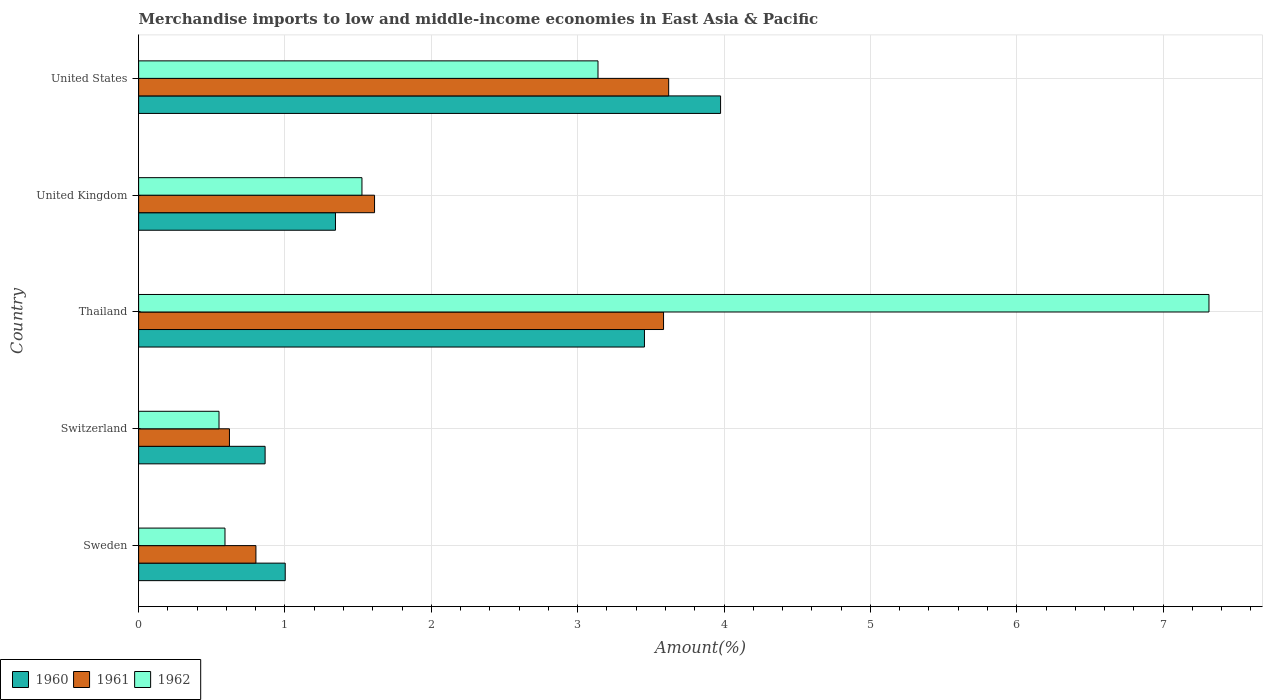How many groups of bars are there?
Ensure brevity in your answer.  5. Are the number of bars on each tick of the Y-axis equal?
Keep it short and to the point. Yes. How many bars are there on the 4th tick from the bottom?
Ensure brevity in your answer.  3. What is the label of the 3rd group of bars from the top?
Your response must be concise. Thailand. What is the percentage of amount earned from merchandise imports in 1961 in United Kingdom?
Keep it short and to the point. 1.61. Across all countries, what is the maximum percentage of amount earned from merchandise imports in 1962?
Provide a succinct answer. 7.31. Across all countries, what is the minimum percentage of amount earned from merchandise imports in 1961?
Your answer should be compact. 0.62. In which country was the percentage of amount earned from merchandise imports in 1961 minimum?
Give a very brief answer. Switzerland. What is the total percentage of amount earned from merchandise imports in 1960 in the graph?
Your response must be concise. 10.64. What is the difference between the percentage of amount earned from merchandise imports in 1962 in Switzerland and that in United Kingdom?
Ensure brevity in your answer.  -0.98. What is the difference between the percentage of amount earned from merchandise imports in 1962 in United Kingdom and the percentage of amount earned from merchandise imports in 1961 in Switzerland?
Provide a short and direct response. 0.91. What is the average percentage of amount earned from merchandise imports in 1960 per country?
Offer a terse response. 2.13. What is the difference between the percentage of amount earned from merchandise imports in 1961 and percentage of amount earned from merchandise imports in 1962 in United Kingdom?
Make the answer very short. 0.09. In how many countries, is the percentage of amount earned from merchandise imports in 1960 greater than 4.2 %?
Keep it short and to the point. 0. What is the ratio of the percentage of amount earned from merchandise imports in 1962 in Sweden to that in Thailand?
Offer a terse response. 0.08. Is the percentage of amount earned from merchandise imports in 1962 in Sweden less than that in Switzerland?
Your answer should be very brief. No. Is the difference between the percentage of amount earned from merchandise imports in 1961 in Thailand and United States greater than the difference between the percentage of amount earned from merchandise imports in 1962 in Thailand and United States?
Provide a succinct answer. No. What is the difference between the highest and the second highest percentage of amount earned from merchandise imports in 1962?
Offer a very short reply. 4.17. What is the difference between the highest and the lowest percentage of amount earned from merchandise imports in 1962?
Your response must be concise. 6.76. Is the sum of the percentage of amount earned from merchandise imports in 1961 in Sweden and Thailand greater than the maximum percentage of amount earned from merchandise imports in 1960 across all countries?
Your answer should be compact. Yes. What does the 3rd bar from the top in Switzerland represents?
Your answer should be compact. 1960. What does the 1st bar from the bottom in United States represents?
Keep it short and to the point. 1960. Is it the case that in every country, the sum of the percentage of amount earned from merchandise imports in 1960 and percentage of amount earned from merchandise imports in 1961 is greater than the percentage of amount earned from merchandise imports in 1962?
Your answer should be compact. No. Are the values on the major ticks of X-axis written in scientific E-notation?
Ensure brevity in your answer.  No. Does the graph contain grids?
Give a very brief answer. Yes. Where does the legend appear in the graph?
Your answer should be compact. Bottom left. How many legend labels are there?
Offer a terse response. 3. How are the legend labels stacked?
Make the answer very short. Horizontal. What is the title of the graph?
Offer a terse response. Merchandise imports to low and middle-income economies in East Asia & Pacific. Does "1987" appear as one of the legend labels in the graph?
Make the answer very short. No. What is the label or title of the X-axis?
Give a very brief answer. Amount(%). What is the label or title of the Y-axis?
Provide a succinct answer. Country. What is the Amount(%) in 1960 in Sweden?
Your answer should be compact. 1. What is the Amount(%) of 1961 in Sweden?
Offer a very short reply. 0.8. What is the Amount(%) of 1962 in Sweden?
Give a very brief answer. 0.59. What is the Amount(%) in 1960 in Switzerland?
Your answer should be compact. 0.86. What is the Amount(%) in 1961 in Switzerland?
Offer a terse response. 0.62. What is the Amount(%) in 1962 in Switzerland?
Provide a short and direct response. 0.55. What is the Amount(%) of 1960 in Thailand?
Provide a short and direct response. 3.46. What is the Amount(%) in 1961 in Thailand?
Ensure brevity in your answer.  3.59. What is the Amount(%) of 1962 in Thailand?
Provide a succinct answer. 7.31. What is the Amount(%) of 1960 in United Kingdom?
Your response must be concise. 1.34. What is the Amount(%) in 1961 in United Kingdom?
Ensure brevity in your answer.  1.61. What is the Amount(%) of 1962 in United Kingdom?
Your response must be concise. 1.53. What is the Amount(%) of 1960 in United States?
Offer a very short reply. 3.98. What is the Amount(%) in 1961 in United States?
Offer a very short reply. 3.62. What is the Amount(%) of 1962 in United States?
Ensure brevity in your answer.  3.14. Across all countries, what is the maximum Amount(%) of 1960?
Provide a short and direct response. 3.98. Across all countries, what is the maximum Amount(%) of 1961?
Provide a succinct answer. 3.62. Across all countries, what is the maximum Amount(%) of 1962?
Give a very brief answer. 7.31. Across all countries, what is the minimum Amount(%) of 1960?
Provide a short and direct response. 0.86. Across all countries, what is the minimum Amount(%) of 1961?
Offer a terse response. 0.62. Across all countries, what is the minimum Amount(%) in 1962?
Your answer should be compact. 0.55. What is the total Amount(%) in 1960 in the graph?
Give a very brief answer. 10.64. What is the total Amount(%) of 1961 in the graph?
Your answer should be compact. 10.24. What is the total Amount(%) in 1962 in the graph?
Offer a very short reply. 13.12. What is the difference between the Amount(%) of 1960 in Sweden and that in Switzerland?
Your answer should be very brief. 0.14. What is the difference between the Amount(%) in 1961 in Sweden and that in Switzerland?
Provide a succinct answer. 0.18. What is the difference between the Amount(%) of 1962 in Sweden and that in Switzerland?
Ensure brevity in your answer.  0.04. What is the difference between the Amount(%) of 1960 in Sweden and that in Thailand?
Your answer should be compact. -2.45. What is the difference between the Amount(%) of 1961 in Sweden and that in Thailand?
Your response must be concise. -2.79. What is the difference between the Amount(%) in 1962 in Sweden and that in Thailand?
Ensure brevity in your answer.  -6.72. What is the difference between the Amount(%) in 1960 in Sweden and that in United Kingdom?
Keep it short and to the point. -0.34. What is the difference between the Amount(%) in 1961 in Sweden and that in United Kingdom?
Ensure brevity in your answer.  -0.81. What is the difference between the Amount(%) in 1962 in Sweden and that in United Kingdom?
Make the answer very short. -0.94. What is the difference between the Amount(%) of 1960 in Sweden and that in United States?
Provide a succinct answer. -2.97. What is the difference between the Amount(%) in 1961 in Sweden and that in United States?
Your answer should be compact. -2.82. What is the difference between the Amount(%) in 1962 in Sweden and that in United States?
Your answer should be compact. -2.55. What is the difference between the Amount(%) in 1960 in Switzerland and that in Thailand?
Provide a succinct answer. -2.59. What is the difference between the Amount(%) of 1961 in Switzerland and that in Thailand?
Give a very brief answer. -2.97. What is the difference between the Amount(%) of 1962 in Switzerland and that in Thailand?
Your answer should be compact. -6.76. What is the difference between the Amount(%) of 1960 in Switzerland and that in United Kingdom?
Make the answer very short. -0.48. What is the difference between the Amount(%) of 1961 in Switzerland and that in United Kingdom?
Ensure brevity in your answer.  -0.99. What is the difference between the Amount(%) of 1962 in Switzerland and that in United Kingdom?
Your response must be concise. -0.98. What is the difference between the Amount(%) of 1960 in Switzerland and that in United States?
Your answer should be very brief. -3.11. What is the difference between the Amount(%) of 1961 in Switzerland and that in United States?
Provide a succinct answer. -3. What is the difference between the Amount(%) in 1962 in Switzerland and that in United States?
Provide a succinct answer. -2.59. What is the difference between the Amount(%) in 1960 in Thailand and that in United Kingdom?
Provide a succinct answer. 2.11. What is the difference between the Amount(%) in 1961 in Thailand and that in United Kingdom?
Keep it short and to the point. 1.97. What is the difference between the Amount(%) of 1962 in Thailand and that in United Kingdom?
Provide a short and direct response. 5.79. What is the difference between the Amount(%) of 1960 in Thailand and that in United States?
Provide a succinct answer. -0.52. What is the difference between the Amount(%) in 1961 in Thailand and that in United States?
Your answer should be very brief. -0.04. What is the difference between the Amount(%) of 1962 in Thailand and that in United States?
Your response must be concise. 4.17. What is the difference between the Amount(%) of 1960 in United Kingdom and that in United States?
Your response must be concise. -2.63. What is the difference between the Amount(%) in 1961 in United Kingdom and that in United States?
Provide a short and direct response. -2.01. What is the difference between the Amount(%) in 1962 in United Kingdom and that in United States?
Offer a terse response. -1.61. What is the difference between the Amount(%) in 1960 in Sweden and the Amount(%) in 1961 in Switzerland?
Provide a succinct answer. 0.38. What is the difference between the Amount(%) in 1960 in Sweden and the Amount(%) in 1962 in Switzerland?
Make the answer very short. 0.45. What is the difference between the Amount(%) in 1961 in Sweden and the Amount(%) in 1962 in Switzerland?
Your response must be concise. 0.25. What is the difference between the Amount(%) of 1960 in Sweden and the Amount(%) of 1961 in Thailand?
Give a very brief answer. -2.59. What is the difference between the Amount(%) in 1960 in Sweden and the Amount(%) in 1962 in Thailand?
Give a very brief answer. -6.31. What is the difference between the Amount(%) of 1961 in Sweden and the Amount(%) of 1962 in Thailand?
Make the answer very short. -6.51. What is the difference between the Amount(%) of 1960 in Sweden and the Amount(%) of 1961 in United Kingdom?
Keep it short and to the point. -0.61. What is the difference between the Amount(%) in 1960 in Sweden and the Amount(%) in 1962 in United Kingdom?
Provide a short and direct response. -0.52. What is the difference between the Amount(%) of 1961 in Sweden and the Amount(%) of 1962 in United Kingdom?
Your answer should be very brief. -0.72. What is the difference between the Amount(%) in 1960 in Sweden and the Amount(%) in 1961 in United States?
Your answer should be very brief. -2.62. What is the difference between the Amount(%) of 1960 in Sweden and the Amount(%) of 1962 in United States?
Make the answer very short. -2.14. What is the difference between the Amount(%) in 1961 in Sweden and the Amount(%) in 1962 in United States?
Your response must be concise. -2.34. What is the difference between the Amount(%) of 1960 in Switzerland and the Amount(%) of 1961 in Thailand?
Keep it short and to the point. -2.72. What is the difference between the Amount(%) of 1960 in Switzerland and the Amount(%) of 1962 in Thailand?
Keep it short and to the point. -6.45. What is the difference between the Amount(%) in 1961 in Switzerland and the Amount(%) in 1962 in Thailand?
Make the answer very short. -6.69. What is the difference between the Amount(%) of 1960 in Switzerland and the Amount(%) of 1961 in United Kingdom?
Provide a succinct answer. -0.75. What is the difference between the Amount(%) in 1960 in Switzerland and the Amount(%) in 1962 in United Kingdom?
Your answer should be very brief. -0.66. What is the difference between the Amount(%) of 1961 in Switzerland and the Amount(%) of 1962 in United Kingdom?
Ensure brevity in your answer.  -0.91. What is the difference between the Amount(%) of 1960 in Switzerland and the Amount(%) of 1961 in United States?
Offer a very short reply. -2.76. What is the difference between the Amount(%) in 1960 in Switzerland and the Amount(%) in 1962 in United States?
Your response must be concise. -2.27. What is the difference between the Amount(%) in 1961 in Switzerland and the Amount(%) in 1962 in United States?
Make the answer very short. -2.52. What is the difference between the Amount(%) of 1960 in Thailand and the Amount(%) of 1961 in United Kingdom?
Provide a short and direct response. 1.84. What is the difference between the Amount(%) in 1960 in Thailand and the Amount(%) in 1962 in United Kingdom?
Make the answer very short. 1.93. What is the difference between the Amount(%) of 1961 in Thailand and the Amount(%) of 1962 in United Kingdom?
Make the answer very short. 2.06. What is the difference between the Amount(%) of 1960 in Thailand and the Amount(%) of 1961 in United States?
Give a very brief answer. -0.17. What is the difference between the Amount(%) of 1960 in Thailand and the Amount(%) of 1962 in United States?
Offer a very short reply. 0.32. What is the difference between the Amount(%) of 1961 in Thailand and the Amount(%) of 1962 in United States?
Provide a succinct answer. 0.45. What is the difference between the Amount(%) of 1960 in United Kingdom and the Amount(%) of 1961 in United States?
Your answer should be compact. -2.28. What is the difference between the Amount(%) of 1960 in United Kingdom and the Amount(%) of 1962 in United States?
Keep it short and to the point. -1.79. What is the difference between the Amount(%) in 1961 in United Kingdom and the Amount(%) in 1962 in United States?
Make the answer very short. -1.53. What is the average Amount(%) in 1960 per country?
Your answer should be very brief. 2.13. What is the average Amount(%) of 1961 per country?
Provide a short and direct response. 2.05. What is the average Amount(%) of 1962 per country?
Ensure brevity in your answer.  2.62. What is the difference between the Amount(%) of 1960 and Amount(%) of 1961 in Sweden?
Make the answer very short. 0.2. What is the difference between the Amount(%) in 1960 and Amount(%) in 1962 in Sweden?
Provide a short and direct response. 0.41. What is the difference between the Amount(%) in 1961 and Amount(%) in 1962 in Sweden?
Keep it short and to the point. 0.21. What is the difference between the Amount(%) of 1960 and Amount(%) of 1961 in Switzerland?
Provide a succinct answer. 0.24. What is the difference between the Amount(%) of 1960 and Amount(%) of 1962 in Switzerland?
Offer a very short reply. 0.31. What is the difference between the Amount(%) of 1961 and Amount(%) of 1962 in Switzerland?
Keep it short and to the point. 0.07. What is the difference between the Amount(%) of 1960 and Amount(%) of 1961 in Thailand?
Your answer should be very brief. -0.13. What is the difference between the Amount(%) in 1960 and Amount(%) in 1962 in Thailand?
Give a very brief answer. -3.86. What is the difference between the Amount(%) in 1961 and Amount(%) in 1962 in Thailand?
Offer a very short reply. -3.73. What is the difference between the Amount(%) in 1960 and Amount(%) in 1961 in United Kingdom?
Keep it short and to the point. -0.27. What is the difference between the Amount(%) in 1960 and Amount(%) in 1962 in United Kingdom?
Your answer should be compact. -0.18. What is the difference between the Amount(%) of 1961 and Amount(%) of 1962 in United Kingdom?
Give a very brief answer. 0.09. What is the difference between the Amount(%) in 1960 and Amount(%) in 1961 in United States?
Ensure brevity in your answer.  0.35. What is the difference between the Amount(%) of 1960 and Amount(%) of 1962 in United States?
Provide a short and direct response. 0.84. What is the difference between the Amount(%) in 1961 and Amount(%) in 1962 in United States?
Provide a short and direct response. 0.48. What is the ratio of the Amount(%) in 1960 in Sweden to that in Switzerland?
Offer a terse response. 1.16. What is the ratio of the Amount(%) of 1961 in Sweden to that in Switzerland?
Ensure brevity in your answer.  1.29. What is the ratio of the Amount(%) in 1962 in Sweden to that in Switzerland?
Offer a very short reply. 1.07. What is the ratio of the Amount(%) in 1960 in Sweden to that in Thailand?
Your answer should be very brief. 0.29. What is the ratio of the Amount(%) of 1961 in Sweden to that in Thailand?
Your response must be concise. 0.22. What is the ratio of the Amount(%) in 1962 in Sweden to that in Thailand?
Give a very brief answer. 0.08. What is the ratio of the Amount(%) of 1960 in Sweden to that in United Kingdom?
Make the answer very short. 0.74. What is the ratio of the Amount(%) of 1961 in Sweden to that in United Kingdom?
Your response must be concise. 0.5. What is the ratio of the Amount(%) of 1962 in Sweden to that in United Kingdom?
Your answer should be compact. 0.39. What is the ratio of the Amount(%) of 1960 in Sweden to that in United States?
Your answer should be very brief. 0.25. What is the ratio of the Amount(%) of 1961 in Sweden to that in United States?
Offer a very short reply. 0.22. What is the ratio of the Amount(%) in 1962 in Sweden to that in United States?
Offer a very short reply. 0.19. What is the ratio of the Amount(%) in 1960 in Switzerland to that in Thailand?
Offer a terse response. 0.25. What is the ratio of the Amount(%) of 1961 in Switzerland to that in Thailand?
Make the answer very short. 0.17. What is the ratio of the Amount(%) of 1962 in Switzerland to that in Thailand?
Provide a short and direct response. 0.08. What is the ratio of the Amount(%) in 1960 in Switzerland to that in United Kingdom?
Provide a short and direct response. 0.64. What is the ratio of the Amount(%) of 1961 in Switzerland to that in United Kingdom?
Your answer should be very brief. 0.39. What is the ratio of the Amount(%) in 1962 in Switzerland to that in United Kingdom?
Offer a very short reply. 0.36. What is the ratio of the Amount(%) of 1960 in Switzerland to that in United States?
Make the answer very short. 0.22. What is the ratio of the Amount(%) of 1961 in Switzerland to that in United States?
Give a very brief answer. 0.17. What is the ratio of the Amount(%) in 1962 in Switzerland to that in United States?
Offer a very short reply. 0.17. What is the ratio of the Amount(%) of 1960 in Thailand to that in United Kingdom?
Your response must be concise. 2.57. What is the ratio of the Amount(%) of 1961 in Thailand to that in United Kingdom?
Your response must be concise. 2.23. What is the ratio of the Amount(%) of 1962 in Thailand to that in United Kingdom?
Ensure brevity in your answer.  4.79. What is the ratio of the Amount(%) of 1960 in Thailand to that in United States?
Provide a short and direct response. 0.87. What is the ratio of the Amount(%) of 1961 in Thailand to that in United States?
Make the answer very short. 0.99. What is the ratio of the Amount(%) of 1962 in Thailand to that in United States?
Your answer should be compact. 2.33. What is the ratio of the Amount(%) in 1960 in United Kingdom to that in United States?
Keep it short and to the point. 0.34. What is the ratio of the Amount(%) in 1961 in United Kingdom to that in United States?
Provide a short and direct response. 0.45. What is the ratio of the Amount(%) of 1962 in United Kingdom to that in United States?
Keep it short and to the point. 0.49. What is the difference between the highest and the second highest Amount(%) in 1960?
Your answer should be very brief. 0.52. What is the difference between the highest and the second highest Amount(%) in 1961?
Your response must be concise. 0.04. What is the difference between the highest and the second highest Amount(%) in 1962?
Your response must be concise. 4.17. What is the difference between the highest and the lowest Amount(%) of 1960?
Your answer should be compact. 3.11. What is the difference between the highest and the lowest Amount(%) of 1961?
Your answer should be compact. 3. What is the difference between the highest and the lowest Amount(%) of 1962?
Provide a succinct answer. 6.76. 